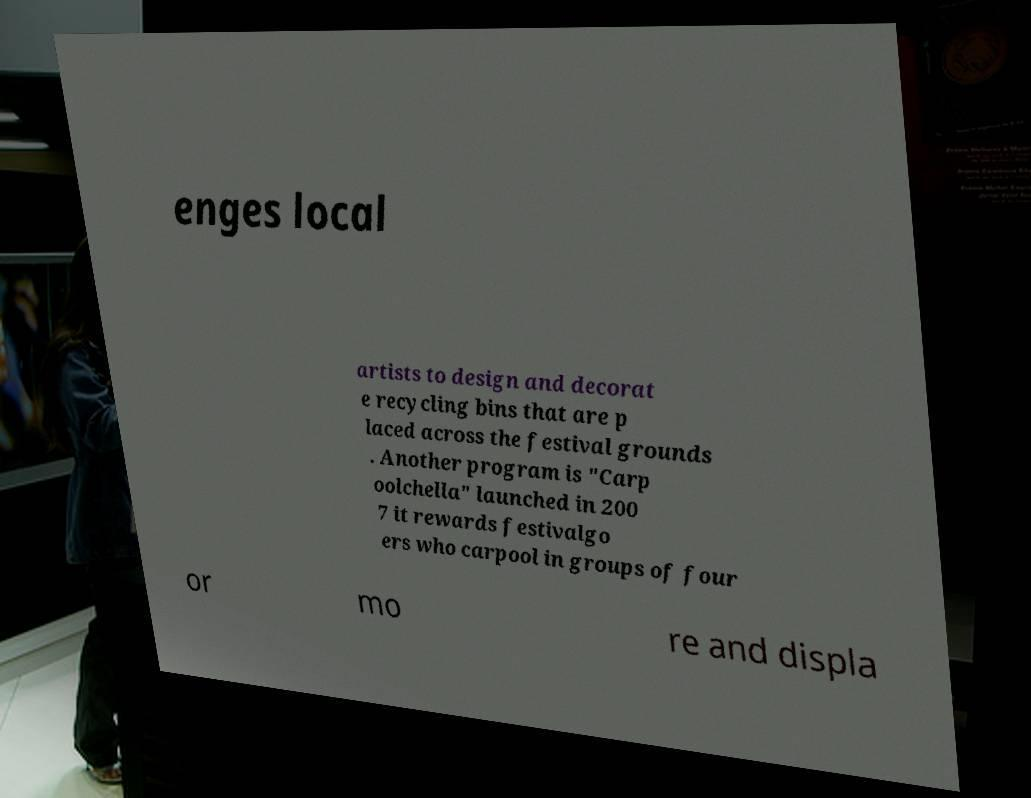I need the written content from this picture converted into text. Can you do that? enges local artists to design and decorat e recycling bins that are p laced across the festival grounds . Another program is "Carp oolchella" launched in 200 7 it rewards festivalgo ers who carpool in groups of four or mo re and displa 